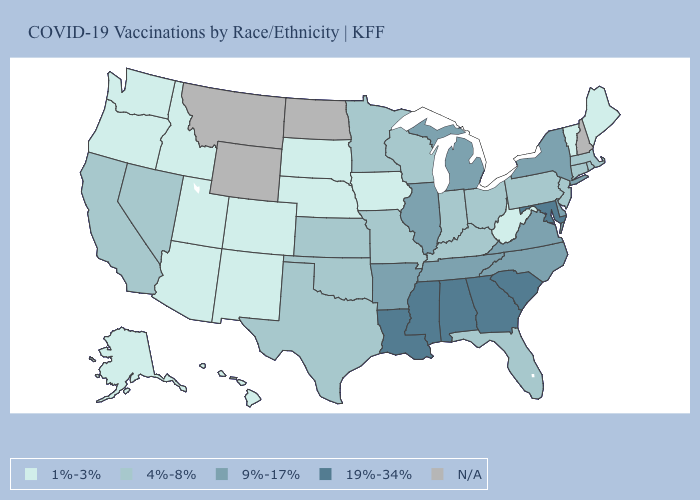Which states hav the highest value in the Northeast?
Give a very brief answer. New York. Which states have the lowest value in the USA?
Quick response, please. Alaska, Arizona, Colorado, Hawaii, Idaho, Iowa, Maine, Nebraska, New Mexico, Oregon, South Dakota, Utah, Vermont, Washington, West Virginia. Name the states that have a value in the range 4%-8%?
Be succinct. California, Connecticut, Florida, Indiana, Kansas, Kentucky, Massachusetts, Minnesota, Missouri, Nevada, New Jersey, Ohio, Oklahoma, Pennsylvania, Rhode Island, Texas, Wisconsin. What is the value of Louisiana?
Be succinct. 19%-34%. What is the lowest value in the USA?
Give a very brief answer. 1%-3%. Is the legend a continuous bar?
Keep it brief. No. Which states have the lowest value in the USA?
Quick response, please. Alaska, Arizona, Colorado, Hawaii, Idaho, Iowa, Maine, Nebraska, New Mexico, Oregon, South Dakota, Utah, Vermont, Washington, West Virginia. What is the value of New York?
Be succinct. 9%-17%. Which states have the highest value in the USA?
Answer briefly. Alabama, Georgia, Louisiana, Maryland, Mississippi, South Carolina. What is the lowest value in the MidWest?
Short answer required. 1%-3%. What is the lowest value in the USA?
Be succinct. 1%-3%. What is the value of Hawaii?
Concise answer only. 1%-3%. Does Idaho have the lowest value in the USA?
Answer briefly. Yes. Name the states that have a value in the range 9%-17%?
Answer briefly. Arkansas, Delaware, Illinois, Michigan, New York, North Carolina, Tennessee, Virginia. What is the highest value in the South ?
Write a very short answer. 19%-34%. 